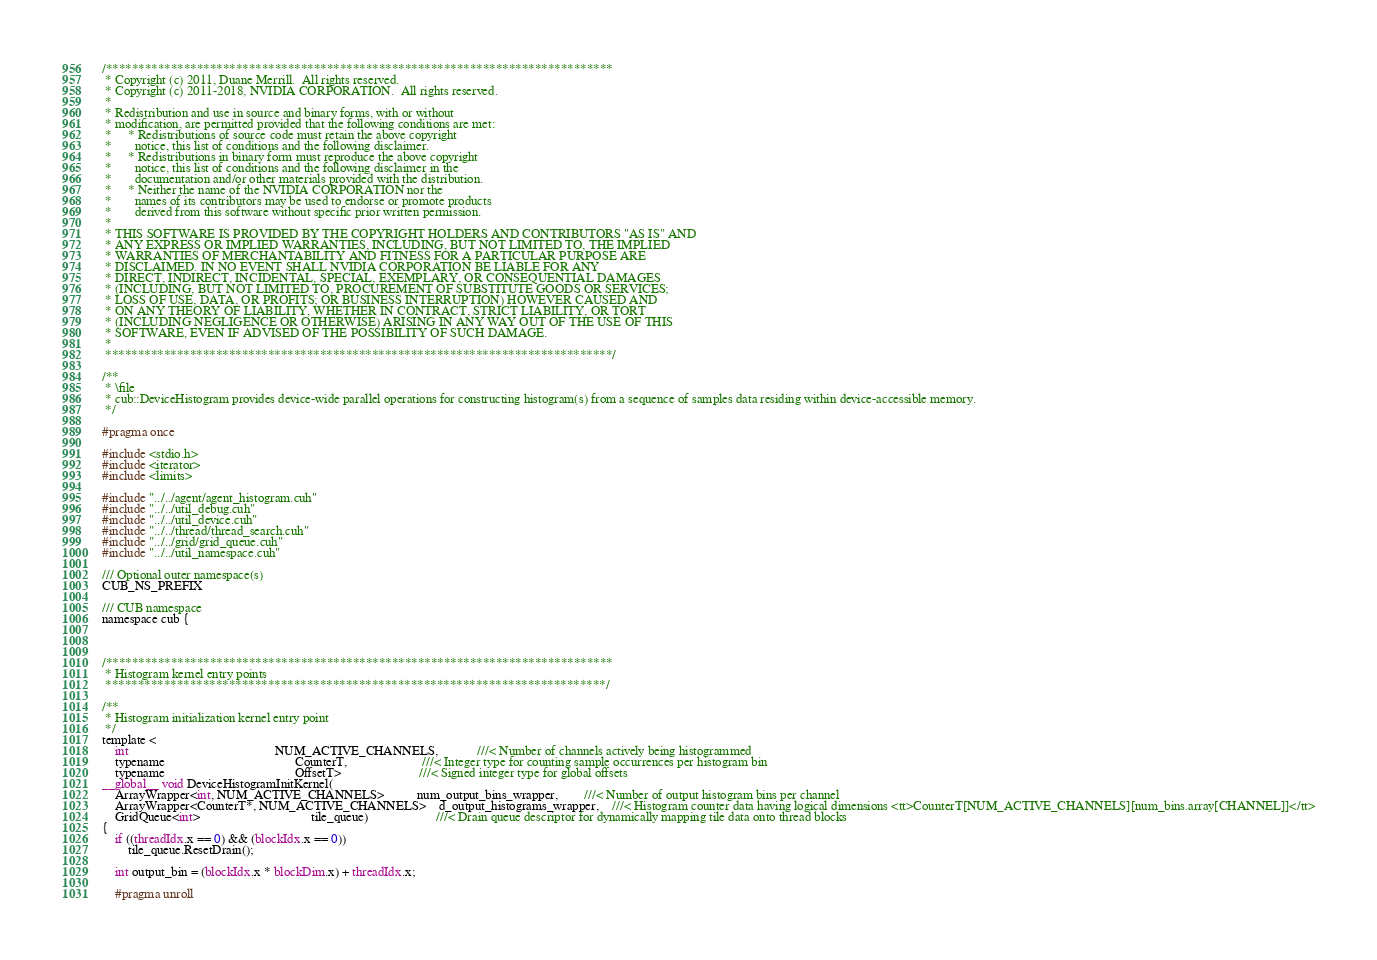<code> <loc_0><loc_0><loc_500><loc_500><_Cuda_>
/******************************************************************************
 * Copyright (c) 2011, Duane Merrill.  All rights reserved.
 * Copyright (c) 2011-2018, NVIDIA CORPORATION.  All rights reserved.
 *
 * Redistribution and use in source and binary forms, with or without
 * modification, are permitted provided that the following conditions are met:
 *     * Redistributions of source code must retain the above copyright
 *       notice, this list of conditions and the following disclaimer.
 *     * Redistributions in binary form must reproduce the above copyright
 *       notice, this list of conditions and the following disclaimer in the
 *       documentation and/or other materials provided with the distribution.
 *     * Neither the name of the NVIDIA CORPORATION nor the
 *       names of its contributors may be used to endorse or promote products
 *       derived from this software without specific prior written permission.
 *
 * THIS SOFTWARE IS PROVIDED BY THE COPYRIGHT HOLDERS AND CONTRIBUTORS "AS IS" AND
 * ANY EXPRESS OR IMPLIED WARRANTIES, INCLUDING, BUT NOT LIMITED TO, THE IMPLIED
 * WARRANTIES OF MERCHANTABILITY AND FITNESS FOR A PARTICULAR PURPOSE ARE
 * DISCLAIMED. IN NO EVENT SHALL NVIDIA CORPORATION BE LIABLE FOR ANY
 * DIRECT, INDIRECT, INCIDENTAL, SPECIAL, EXEMPLARY, OR CONSEQUENTIAL DAMAGES
 * (INCLUDING, BUT NOT LIMITED TO, PROCUREMENT OF SUBSTITUTE GOODS OR SERVICES;
 * LOSS OF USE, DATA, OR PROFITS; OR BUSINESS INTERRUPTION) HOWEVER CAUSED AND
 * ON ANY THEORY OF LIABILITY, WHETHER IN CONTRACT, STRICT LIABILITY, OR TORT
 * (INCLUDING NEGLIGENCE OR OTHERWISE) ARISING IN ANY WAY OUT OF THE USE OF THIS
 * SOFTWARE, EVEN IF ADVISED OF THE POSSIBILITY OF SUCH DAMAGE.
 *
 ******************************************************************************/

/**
 * \file
 * cub::DeviceHistogram provides device-wide parallel operations for constructing histogram(s) from a sequence of samples data residing within device-accessible memory.
 */

#pragma once

#include <stdio.h>
#include <iterator>
#include <limits>

#include "../../agent/agent_histogram.cuh"
#include "../../util_debug.cuh"
#include "../../util_device.cuh"
#include "../../thread/thread_search.cuh"
#include "../../grid/grid_queue.cuh"
#include "../../util_namespace.cuh"

/// Optional outer namespace(s)
CUB_NS_PREFIX

/// CUB namespace
namespace cub {



/******************************************************************************
 * Histogram kernel entry points
 *****************************************************************************/

/**
 * Histogram initialization kernel entry point
 */
template <
    int                                             NUM_ACTIVE_CHANNELS,            ///< Number of channels actively being histogrammed
    typename                                        CounterT,                       ///< Integer type for counting sample occurrences per histogram bin
    typename                                        OffsetT>                        ///< Signed integer type for global offsets
__global__ void DeviceHistogramInitKernel(
    ArrayWrapper<int, NUM_ACTIVE_CHANNELS>          num_output_bins_wrapper,        ///< Number of output histogram bins per channel
    ArrayWrapper<CounterT*, NUM_ACTIVE_CHANNELS>    d_output_histograms_wrapper,    ///< Histogram counter data having logical dimensions <tt>CounterT[NUM_ACTIVE_CHANNELS][num_bins.array[CHANNEL]]</tt>
    GridQueue<int>                                  tile_queue)                     ///< Drain queue descriptor for dynamically mapping tile data onto thread blocks
{
    if ((threadIdx.x == 0) && (blockIdx.x == 0))
        tile_queue.ResetDrain();

    int output_bin = (blockIdx.x * blockDim.x) + threadIdx.x;

    #pragma unroll</code> 